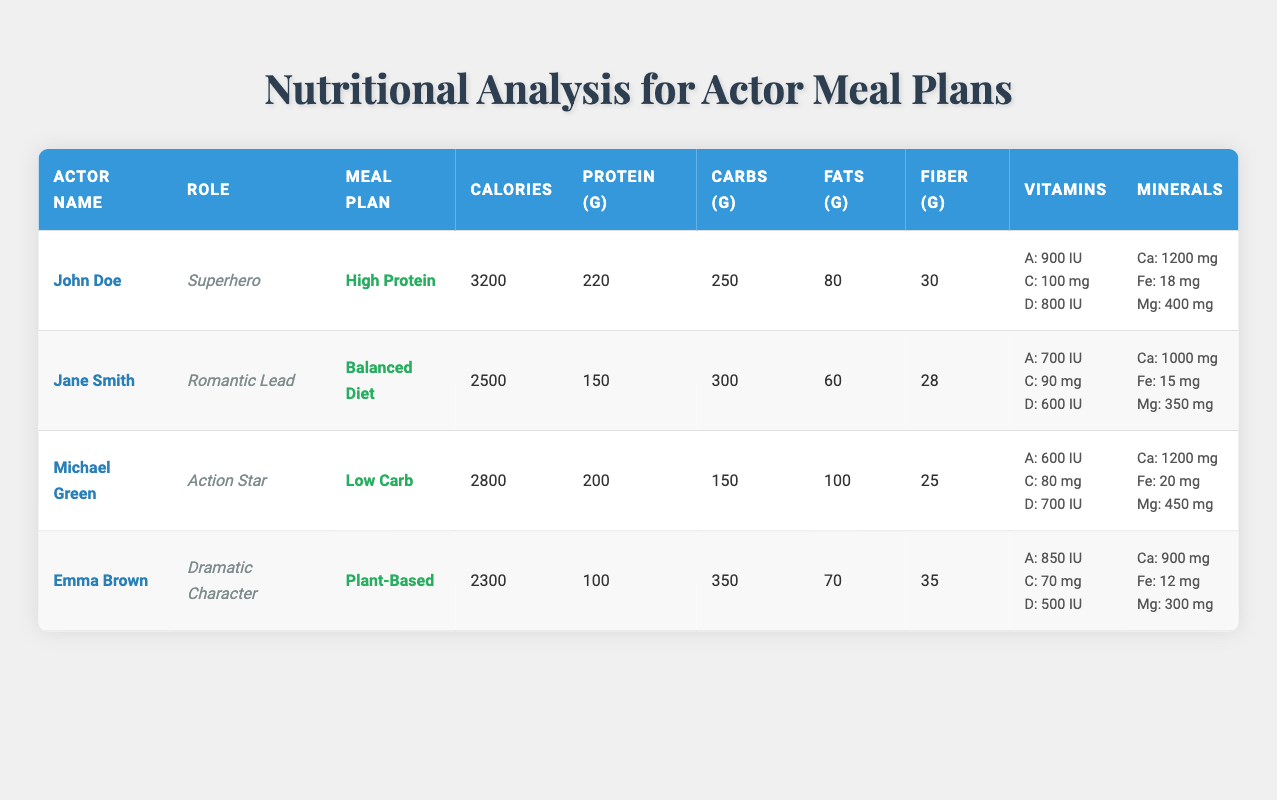What is the total protein intake for all actors in the meal plans? To find the total protein intake, I need to sum the protein values for each actor in the table: 220 + 150 + 200 + 100 = 670 grams
Answer: 670 grams Which actor has the highest calorie consumption? By examining the table, I can see that John Doe has the highest calorie consumption with 3200 calories, compared to other actors with lower values
Answer: John Doe Is the role of Emma Brown categorized as an Action Star? Looking at the table, Emma Brown's role is listed as a Dramatic Character, not an Action Star
Answer: No What is the average carbohydrate intake across all meal plans? To calculate the average carbohydrate intake, I add the carbohydrate values: 250 + 300 + 150 + 350 = 1050 grams. There are 4 actors, so I divide: 1050/4 = 262.5 grams
Answer: 262.5 grams How many grams of fiber does Michael Green's meal plan contain? From the table, Michael Green's meal plan lists a fiber intake of 25 grams
Answer: 25 grams Does Jane Smith have a higher intake of protein than Emma Brown? Comparing the protein values directly: Jane Smith has 150 grams of protein, while Emma Brown has 100 grams
Answer: Yes What is the total fat intake for all meal plans combined? To find the total fat intake, I sum the fat values from each actor: 80 + 60 + 100 + 70 = 310 grams
Answer: 310 grams Which vitamins does John Doe's meal plan contain that have higher values than those of Emma Brown's? I compare the vitamin values for John Doe and Emma Brown: John Doe has Vitamin A at 900 IU, C at 100 mg, and D at 800 IU, while Emma has A at 850 IU, C at 70 mg, and D at 500 IU. John outperforms Emma in all vitamin categories
Answer: Vitamin A, Vitamin C, Vitamin D What is the difference in calcium intake between Jane Smith and Michael Green? Jane Smith's calcium intake is 1000 mg and Michael Green's is 1200 mg. The difference can be found by subtracting: 1200 - 1000 = 200 mg
Answer: 200 mg 